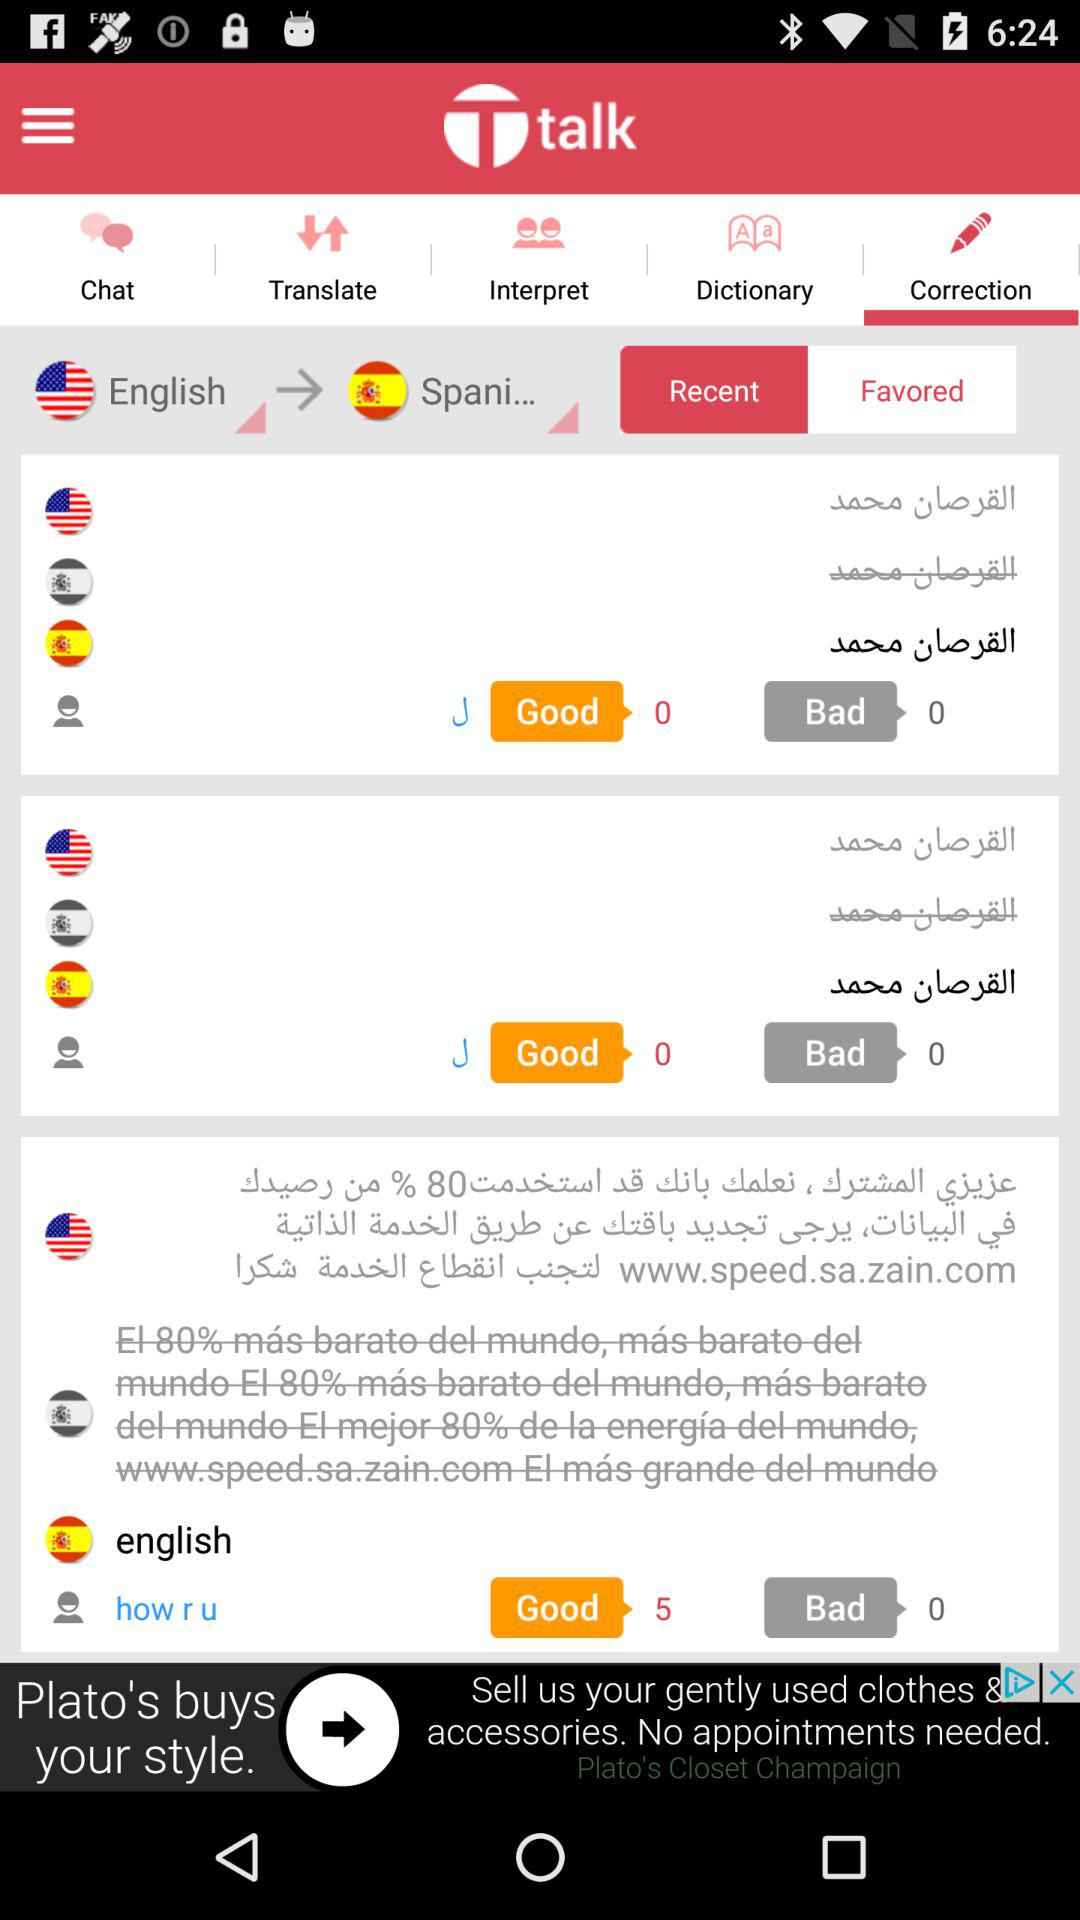What is the application name? The application name is "Ttalk". 